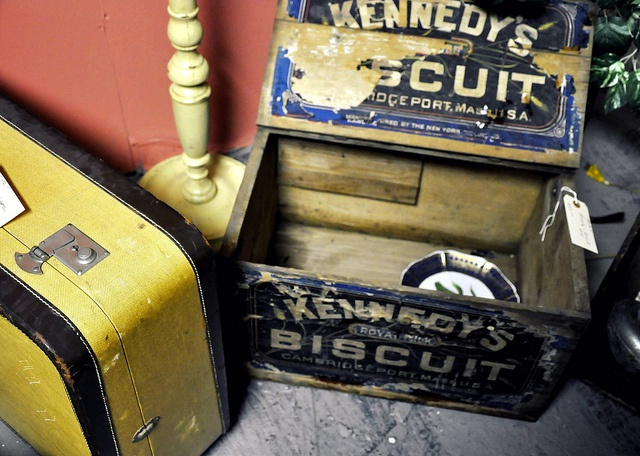Describe the objects in this image and their specific colors. I can see a suitcase in brown, black, olive, and khaki tones in this image. 